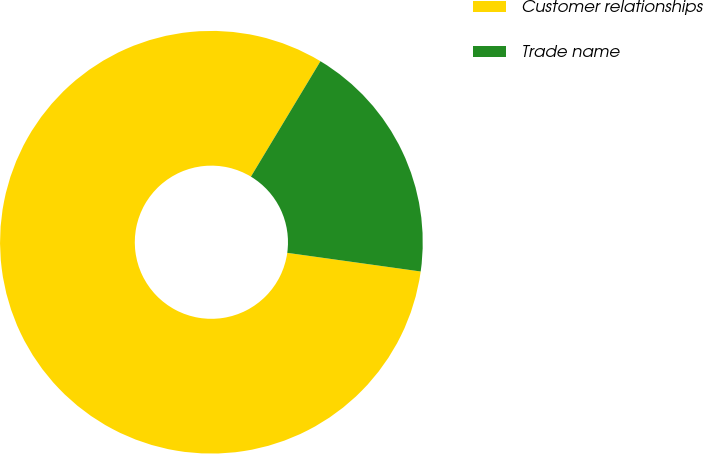<chart> <loc_0><loc_0><loc_500><loc_500><pie_chart><fcel>Customer relationships<fcel>Trade name<nl><fcel>81.42%<fcel>18.58%<nl></chart> 